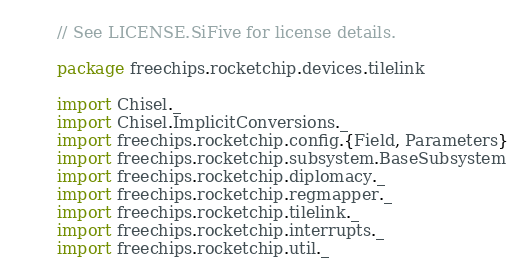<code> <loc_0><loc_0><loc_500><loc_500><_Scala_>// See LICENSE.SiFive for license details.

package freechips.rocketchip.devices.tilelink

import Chisel._
import Chisel.ImplicitConversions._
import freechips.rocketchip.config.{Field, Parameters}
import freechips.rocketchip.subsystem.BaseSubsystem
import freechips.rocketchip.diplomacy._
import freechips.rocketchip.regmapper._
import freechips.rocketchip.tilelink._
import freechips.rocketchip.interrupts._
import freechips.rocketchip.util._</code> 